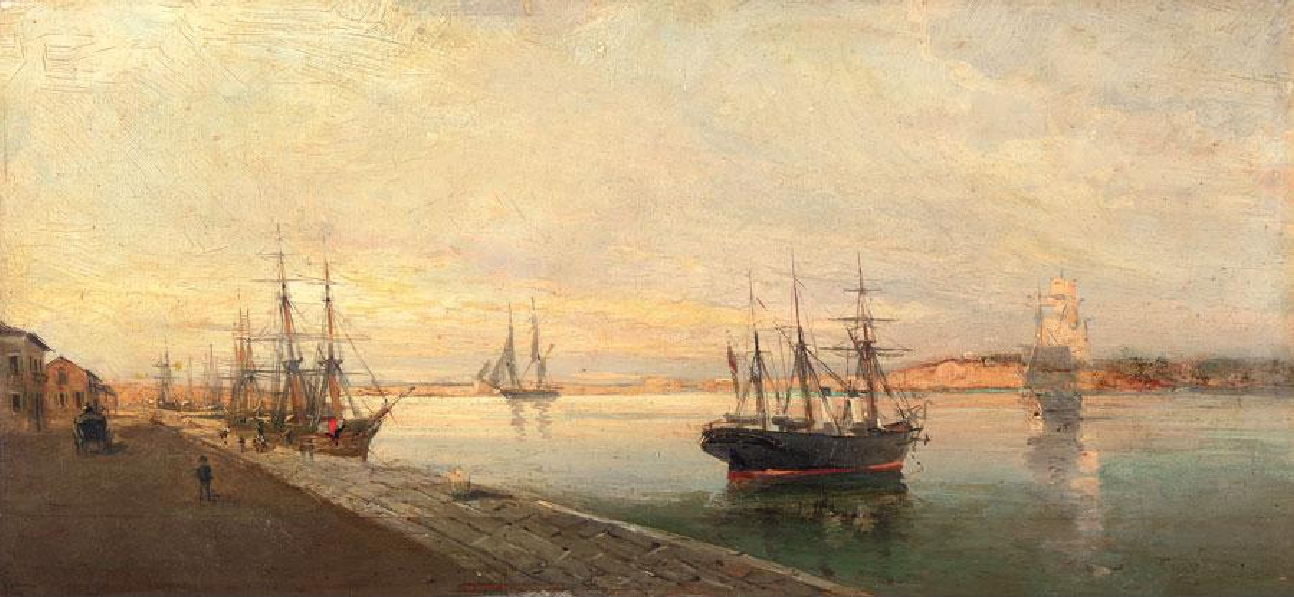Explain the visual content of the image in great detail. This is an oil painting that captures a bustling harbor scene. The canvas is filled with several ships and boats, suggesting a lively maritime activity. The artist has employed an impressionist style, characterized by loose brushstrokes that capture the essence of the subject rather than its details. 

The color palette is dominated by warm hues, with a range of yellows, oranges, and browns that create a sense of warmth and light. This choice of colors, combined with the focus on the effects of light and color, is typical of the impressionist genre.

The painting likely dates back to the late 19th or early 20th century, a period when impressionism was at its peak. The subject matter of the painting, a harbor scene, was a popular choice among artists of this era, who were often drawn to scenes of everyday life and the changing effects of light and color on the landscape. 

Overall, this painting is a beautiful representation of an impressionist harbor scene, filled with light, color, and activity. 